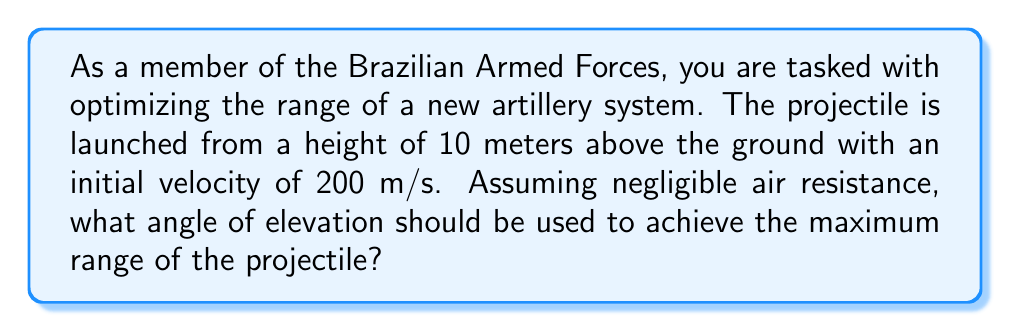Help me with this question. To find the optimal angle for maximum range, we need to use the equations of projectile motion and some trigonometry. Let's approach this step-by-step:

1) The range (R) of a projectile launched from an elevated position is given by:

   $$R = \frac{v_0^2}{g} \left(\sin(2\theta) + \sqrt{\sin^2(2\theta) + \frac{2gh}{v_0^2}}\right)$$

   Where:
   $v_0$ is the initial velocity
   $g$ is the acceleration due to gravity (9.8 m/s²)
   $\theta$ is the angle of elevation
   $h$ is the initial height

2) For maximum range, we need to find the angle $\theta$ that maximizes this expression. In the case where $h = 0$ (launch from ground level), the maximum range occurs at $\theta = 45°$. However, with an elevated launch point, the angle is slightly less than 45°.

3) To find the exact angle, we would need to differentiate the range equation with respect to $\theta$ and set it to zero. However, this leads to a complex equation that's difficult to solve analytically.

4) Instead, we can use the approximation that for small values of $\frac{2gh}{v_0^2}$, the optimal angle is given by:

   $$\theta_{opt} \approx 45° - \frac{1}{4} \arcsin\left(\frac{gh}{v_0^2}\right)$$

5) Let's plug in our values:
   $v_0 = 200$ m/s
   $g = 9.8$ m/s²
   $h = 10$ m

6) Calculate $\frac{gh}{v_0^2}$:
   $$\frac{gh}{v_0^2} = \frac{9.8 \times 10}{200^2} = 0.00245$$

7) Now we can calculate $\theta_{opt}$:
   $$\theta_{opt} \approx 45° - \frac{1}{4} \arcsin(0.00245)$$
   $$\theta_{opt} \approx 45° - 0.035°$$
   $$\theta_{opt} \approx 44.965°$$

Therefore, the optimal angle for maximum range is approximately 44.965°.
Answer: The optimal angle of elevation for maximum range is approximately 44.965°. 